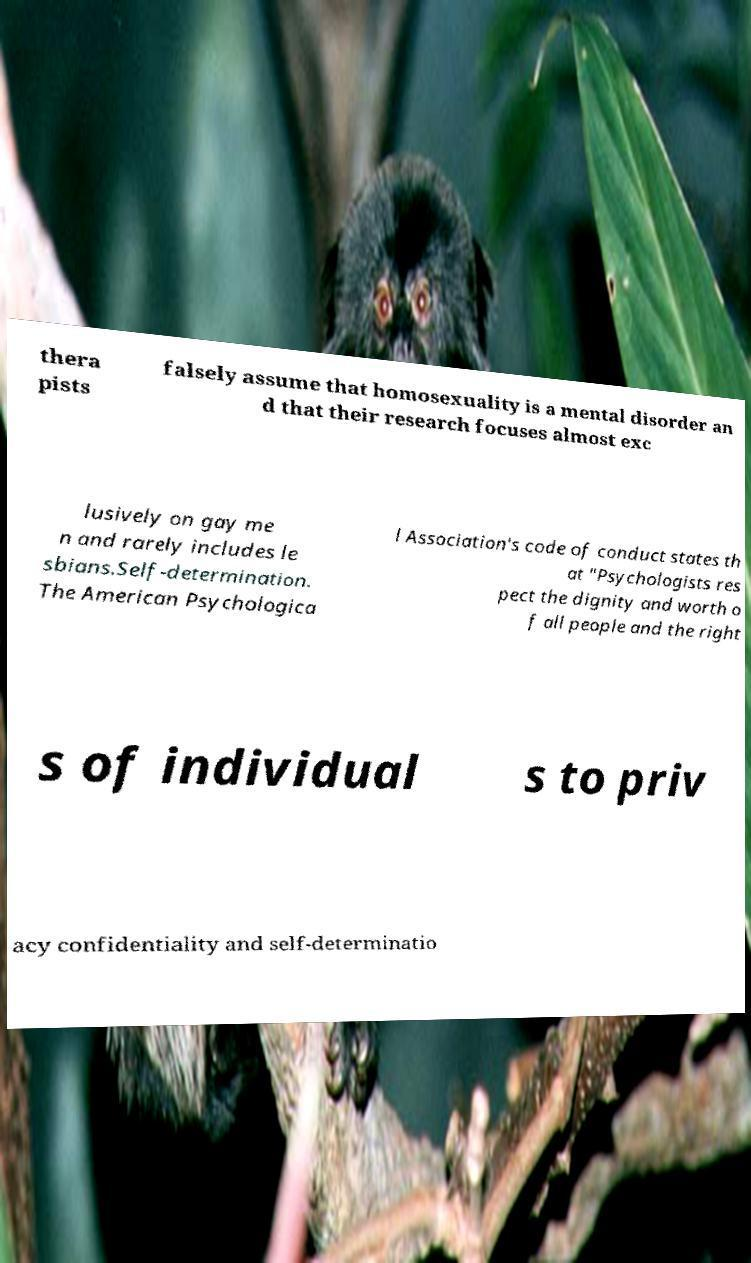Could you assist in decoding the text presented in this image and type it out clearly? thera pists falsely assume that homosexuality is a mental disorder an d that their research focuses almost exc lusively on gay me n and rarely includes le sbians.Self-determination. The American Psychologica l Association's code of conduct states th at "Psychologists res pect the dignity and worth o f all people and the right s of individual s to priv acy confidentiality and self-determinatio 